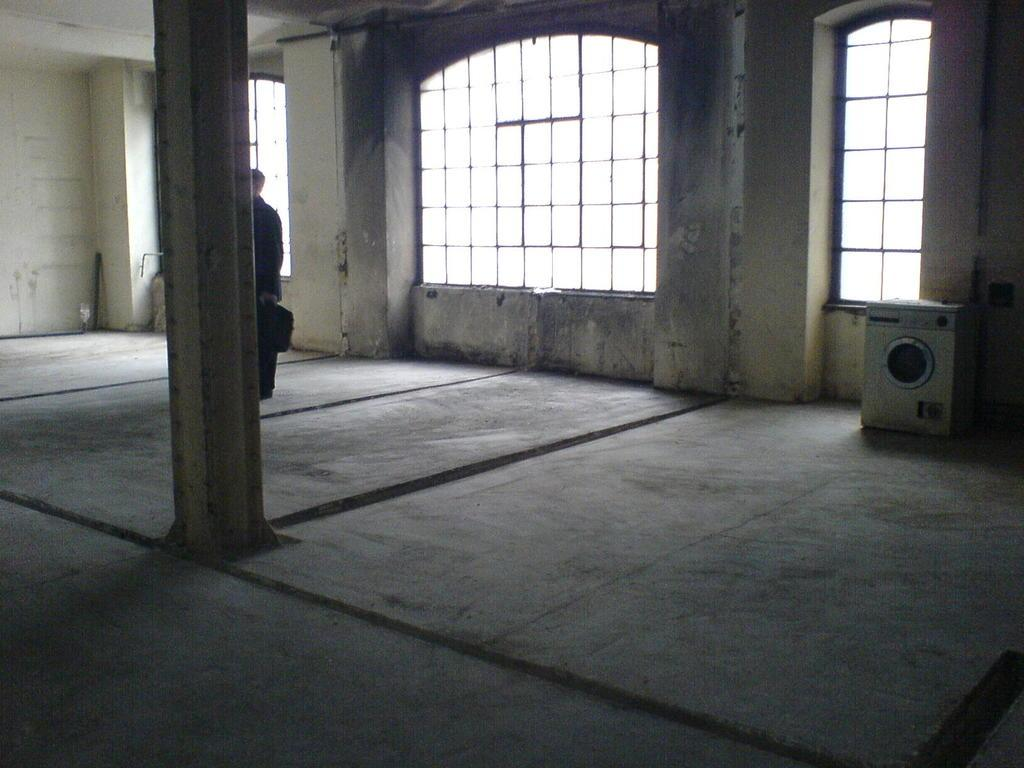What type of space is depicted in the image? The image is of an indoor room. What architectural feature can be seen in the room? There is a pillar in the room. Where is the pillar located in the room? The pillar is located on the left side. Who is present in the room? There is a man in the room. What is the man wearing? The man is wearing a black dress. Is there any source of natural light in the room? Yes, there is a window in the room. How many women are sitting on the nest in the image? There is no nest or women present in the image. 